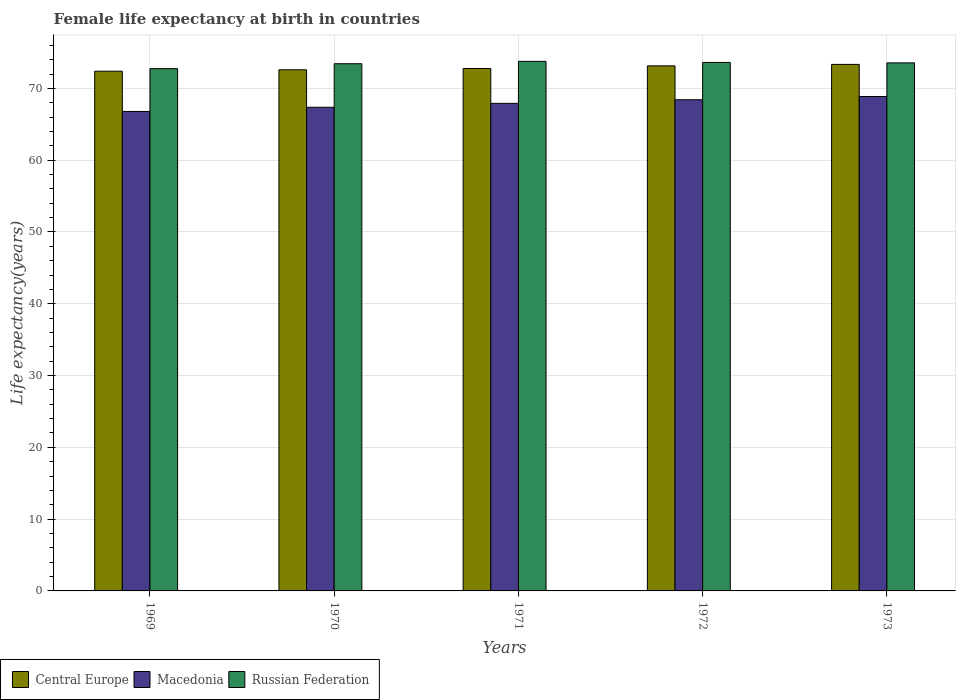How many different coloured bars are there?
Your response must be concise. 3. How many groups of bars are there?
Give a very brief answer. 5. Are the number of bars per tick equal to the number of legend labels?
Keep it short and to the point. Yes. Are the number of bars on each tick of the X-axis equal?
Offer a terse response. Yes. What is the label of the 1st group of bars from the left?
Provide a short and direct response. 1969. What is the female life expectancy at birth in Macedonia in 1971?
Provide a short and direct response. 67.92. Across all years, what is the maximum female life expectancy at birth in Macedonia?
Give a very brief answer. 68.87. Across all years, what is the minimum female life expectancy at birth in Macedonia?
Your answer should be very brief. 66.79. In which year was the female life expectancy at birth in Macedonia maximum?
Make the answer very short. 1973. In which year was the female life expectancy at birth in Macedonia minimum?
Offer a terse response. 1969. What is the total female life expectancy at birth in Macedonia in the graph?
Give a very brief answer. 339.38. What is the difference between the female life expectancy at birth in Russian Federation in 1971 and that in 1973?
Your answer should be compact. 0.21. What is the difference between the female life expectancy at birth in Macedonia in 1970 and the female life expectancy at birth in Central Europe in 1971?
Give a very brief answer. -5.4. What is the average female life expectancy at birth in Macedonia per year?
Make the answer very short. 67.88. In the year 1969, what is the difference between the female life expectancy at birth in Central Europe and female life expectancy at birth in Russian Federation?
Provide a succinct answer. -0.36. In how many years, is the female life expectancy at birth in Macedonia greater than 54 years?
Your answer should be very brief. 5. What is the ratio of the female life expectancy at birth in Central Europe in 1971 to that in 1972?
Make the answer very short. 1. Is the difference between the female life expectancy at birth in Central Europe in 1969 and 1971 greater than the difference between the female life expectancy at birth in Russian Federation in 1969 and 1971?
Give a very brief answer. Yes. What is the difference between the highest and the second highest female life expectancy at birth in Macedonia?
Provide a succinct answer. 0.45. What is the difference between the highest and the lowest female life expectancy at birth in Macedonia?
Make the answer very short. 2.08. Is the sum of the female life expectancy at birth in Russian Federation in 1970 and 1973 greater than the maximum female life expectancy at birth in Macedonia across all years?
Ensure brevity in your answer.  Yes. What does the 1st bar from the left in 1970 represents?
Your response must be concise. Central Europe. What does the 1st bar from the right in 1972 represents?
Provide a succinct answer. Russian Federation. Is it the case that in every year, the sum of the female life expectancy at birth in Central Europe and female life expectancy at birth in Macedonia is greater than the female life expectancy at birth in Russian Federation?
Your answer should be compact. Yes. How many bars are there?
Keep it short and to the point. 15. How many years are there in the graph?
Provide a succinct answer. 5. What is the difference between two consecutive major ticks on the Y-axis?
Offer a very short reply. 10. How many legend labels are there?
Give a very brief answer. 3. How are the legend labels stacked?
Your response must be concise. Horizontal. What is the title of the graph?
Offer a terse response. Female life expectancy at birth in countries. What is the label or title of the Y-axis?
Ensure brevity in your answer.  Life expectancy(years). What is the Life expectancy(years) of Central Europe in 1969?
Your answer should be compact. 72.4. What is the Life expectancy(years) of Macedonia in 1969?
Offer a very short reply. 66.79. What is the Life expectancy(years) of Russian Federation in 1969?
Provide a succinct answer. 72.75. What is the Life expectancy(years) of Central Europe in 1970?
Give a very brief answer. 72.59. What is the Life expectancy(years) of Macedonia in 1970?
Provide a succinct answer. 67.37. What is the Life expectancy(years) of Russian Federation in 1970?
Offer a very short reply. 73.44. What is the Life expectancy(years) of Central Europe in 1971?
Offer a very short reply. 72.78. What is the Life expectancy(years) of Macedonia in 1971?
Keep it short and to the point. 67.92. What is the Life expectancy(years) in Russian Federation in 1971?
Offer a terse response. 73.77. What is the Life expectancy(years) in Central Europe in 1972?
Give a very brief answer. 73.14. What is the Life expectancy(years) of Macedonia in 1972?
Keep it short and to the point. 68.42. What is the Life expectancy(years) in Russian Federation in 1972?
Your answer should be compact. 73.62. What is the Life expectancy(years) of Central Europe in 1973?
Keep it short and to the point. 73.35. What is the Life expectancy(years) in Macedonia in 1973?
Make the answer very short. 68.87. What is the Life expectancy(years) in Russian Federation in 1973?
Make the answer very short. 73.56. Across all years, what is the maximum Life expectancy(years) of Central Europe?
Make the answer very short. 73.35. Across all years, what is the maximum Life expectancy(years) in Macedonia?
Your response must be concise. 68.87. Across all years, what is the maximum Life expectancy(years) in Russian Federation?
Make the answer very short. 73.77. Across all years, what is the minimum Life expectancy(years) of Central Europe?
Give a very brief answer. 72.4. Across all years, what is the minimum Life expectancy(years) in Macedonia?
Make the answer very short. 66.79. Across all years, what is the minimum Life expectancy(years) in Russian Federation?
Ensure brevity in your answer.  72.75. What is the total Life expectancy(years) in Central Europe in the graph?
Your response must be concise. 364.25. What is the total Life expectancy(years) of Macedonia in the graph?
Offer a terse response. 339.38. What is the total Life expectancy(years) of Russian Federation in the graph?
Provide a short and direct response. 367.14. What is the difference between the Life expectancy(years) of Central Europe in 1969 and that in 1970?
Keep it short and to the point. -0.2. What is the difference between the Life expectancy(years) in Macedonia in 1969 and that in 1970?
Your answer should be compact. -0.58. What is the difference between the Life expectancy(years) of Russian Federation in 1969 and that in 1970?
Your answer should be compact. -0.69. What is the difference between the Life expectancy(years) in Central Europe in 1969 and that in 1971?
Offer a very short reply. -0.38. What is the difference between the Life expectancy(years) of Macedonia in 1969 and that in 1971?
Provide a short and direct response. -1.12. What is the difference between the Life expectancy(years) in Russian Federation in 1969 and that in 1971?
Your response must be concise. -1.01. What is the difference between the Life expectancy(years) of Central Europe in 1969 and that in 1972?
Offer a terse response. -0.74. What is the difference between the Life expectancy(years) of Macedonia in 1969 and that in 1972?
Offer a terse response. -1.63. What is the difference between the Life expectancy(years) in Russian Federation in 1969 and that in 1972?
Make the answer very short. -0.86. What is the difference between the Life expectancy(years) in Central Europe in 1969 and that in 1973?
Make the answer very short. -0.95. What is the difference between the Life expectancy(years) in Macedonia in 1969 and that in 1973?
Your answer should be very brief. -2.08. What is the difference between the Life expectancy(years) of Russian Federation in 1969 and that in 1973?
Your answer should be very brief. -0.81. What is the difference between the Life expectancy(years) of Central Europe in 1970 and that in 1971?
Make the answer very short. -0.18. What is the difference between the Life expectancy(years) of Macedonia in 1970 and that in 1971?
Your response must be concise. -0.55. What is the difference between the Life expectancy(years) in Russian Federation in 1970 and that in 1971?
Offer a very short reply. -0.33. What is the difference between the Life expectancy(years) in Central Europe in 1970 and that in 1972?
Give a very brief answer. -0.55. What is the difference between the Life expectancy(years) in Macedonia in 1970 and that in 1972?
Your response must be concise. -1.05. What is the difference between the Life expectancy(years) of Russian Federation in 1970 and that in 1972?
Your response must be concise. -0.18. What is the difference between the Life expectancy(years) of Central Europe in 1970 and that in 1973?
Provide a succinct answer. -0.75. What is the difference between the Life expectancy(years) of Macedonia in 1970 and that in 1973?
Provide a succinct answer. -1.5. What is the difference between the Life expectancy(years) in Russian Federation in 1970 and that in 1973?
Give a very brief answer. -0.12. What is the difference between the Life expectancy(years) of Central Europe in 1971 and that in 1972?
Provide a short and direct response. -0.37. What is the difference between the Life expectancy(years) in Macedonia in 1971 and that in 1972?
Offer a terse response. -0.5. What is the difference between the Life expectancy(years) in Russian Federation in 1971 and that in 1972?
Offer a terse response. 0.15. What is the difference between the Life expectancy(years) of Central Europe in 1971 and that in 1973?
Your answer should be very brief. -0.57. What is the difference between the Life expectancy(years) in Macedonia in 1971 and that in 1973?
Make the answer very short. -0.95. What is the difference between the Life expectancy(years) of Russian Federation in 1971 and that in 1973?
Make the answer very short. 0.21. What is the difference between the Life expectancy(years) in Central Europe in 1972 and that in 1973?
Offer a very short reply. -0.21. What is the difference between the Life expectancy(years) of Macedonia in 1972 and that in 1973?
Provide a short and direct response. -0.45. What is the difference between the Life expectancy(years) of Russian Federation in 1972 and that in 1973?
Your answer should be very brief. 0.06. What is the difference between the Life expectancy(years) of Central Europe in 1969 and the Life expectancy(years) of Macedonia in 1970?
Give a very brief answer. 5.02. What is the difference between the Life expectancy(years) of Central Europe in 1969 and the Life expectancy(years) of Russian Federation in 1970?
Your response must be concise. -1.04. What is the difference between the Life expectancy(years) in Macedonia in 1969 and the Life expectancy(years) in Russian Federation in 1970?
Your response must be concise. -6.65. What is the difference between the Life expectancy(years) in Central Europe in 1969 and the Life expectancy(years) in Macedonia in 1971?
Your answer should be compact. 4.48. What is the difference between the Life expectancy(years) in Central Europe in 1969 and the Life expectancy(years) in Russian Federation in 1971?
Keep it short and to the point. -1.37. What is the difference between the Life expectancy(years) of Macedonia in 1969 and the Life expectancy(years) of Russian Federation in 1971?
Offer a terse response. -6.98. What is the difference between the Life expectancy(years) in Central Europe in 1969 and the Life expectancy(years) in Macedonia in 1972?
Give a very brief answer. 3.98. What is the difference between the Life expectancy(years) of Central Europe in 1969 and the Life expectancy(years) of Russian Federation in 1972?
Your answer should be very brief. -1.22. What is the difference between the Life expectancy(years) of Macedonia in 1969 and the Life expectancy(years) of Russian Federation in 1972?
Offer a terse response. -6.83. What is the difference between the Life expectancy(years) in Central Europe in 1969 and the Life expectancy(years) in Macedonia in 1973?
Ensure brevity in your answer.  3.52. What is the difference between the Life expectancy(years) of Central Europe in 1969 and the Life expectancy(years) of Russian Federation in 1973?
Provide a short and direct response. -1.16. What is the difference between the Life expectancy(years) in Macedonia in 1969 and the Life expectancy(years) in Russian Federation in 1973?
Your answer should be very brief. -6.77. What is the difference between the Life expectancy(years) in Central Europe in 1970 and the Life expectancy(years) in Macedonia in 1971?
Offer a terse response. 4.67. What is the difference between the Life expectancy(years) of Central Europe in 1970 and the Life expectancy(years) of Russian Federation in 1971?
Give a very brief answer. -1.18. What is the difference between the Life expectancy(years) of Macedonia in 1970 and the Life expectancy(years) of Russian Federation in 1971?
Keep it short and to the point. -6.4. What is the difference between the Life expectancy(years) in Central Europe in 1970 and the Life expectancy(years) in Macedonia in 1972?
Offer a terse response. 4.17. What is the difference between the Life expectancy(years) of Central Europe in 1970 and the Life expectancy(years) of Russian Federation in 1972?
Your response must be concise. -1.03. What is the difference between the Life expectancy(years) of Macedonia in 1970 and the Life expectancy(years) of Russian Federation in 1972?
Ensure brevity in your answer.  -6.25. What is the difference between the Life expectancy(years) of Central Europe in 1970 and the Life expectancy(years) of Macedonia in 1973?
Your response must be concise. 3.72. What is the difference between the Life expectancy(years) of Central Europe in 1970 and the Life expectancy(years) of Russian Federation in 1973?
Your answer should be compact. -0.97. What is the difference between the Life expectancy(years) in Macedonia in 1970 and the Life expectancy(years) in Russian Federation in 1973?
Ensure brevity in your answer.  -6.19. What is the difference between the Life expectancy(years) of Central Europe in 1971 and the Life expectancy(years) of Macedonia in 1972?
Ensure brevity in your answer.  4.36. What is the difference between the Life expectancy(years) in Central Europe in 1971 and the Life expectancy(years) in Russian Federation in 1972?
Make the answer very short. -0.84. What is the difference between the Life expectancy(years) in Macedonia in 1971 and the Life expectancy(years) in Russian Federation in 1972?
Offer a very short reply. -5.7. What is the difference between the Life expectancy(years) of Central Europe in 1971 and the Life expectancy(years) of Macedonia in 1973?
Offer a very short reply. 3.9. What is the difference between the Life expectancy(years) of Central Europe in 1971 and the Life expectancy(years) of Russian Federation in 1973?
Your answer should be compact. -0.78. What is the difference between the Life expectancy(years) in Macedonia in 1971 and the Life expectancy(years) in Russian Federation in 1973?
Keep it short and to the point. -5.64. What is the difference between the Life expectancy(years) in Central Europe in 1972 and the Life expectancy(years) in Macedonia in 1973?
Offer a terse response. 4.27. What is the difference between the Life expectancy(years) in Central Europe in 1972 and the Life expectancy(years) in Russian Federation in 1973?
Make the answer very short. -0.42. What is the difference between the Life expectancy(years) of Macedonia in 1972 and the Life expectancy(years) of Russian Federation in 1973?
Give a very brief answer. -5.14. What is the average Life expectancy(years) of Central Europe per year?
Give a very brief answer. 72.85. What is the average Life expectancy(years) of Macedonia per year?
Offer a terse response. 67.88. What is the average Life expectancy(years) of Russian Federation per year?
Your answer should be very brief. 73.43. In the year 1969, what is the difference between the Life expectancy(years) of Central Europe and Life expectancy(years) of Macedonia?
Offer a terse response. 5.6. In the year 1969, what is the difference between the Life expectancy(years) of Central Europe and Life expectancy(years) of Russian Federation?
Provide a short and direct response. -0.36. In the year 1969, what is the difference between the Life expectancy(years) of Macedonia and Life expectancy(years) of Russian Federation?
Make the answer very short. -5.96. In the year 1970, what is the difference between the Life expectancy(years) of Central Europe and Life expectancy(years) of Macedonia?
Your answer should be very brief. 5.22. In the year 1970, what is the difference between the Life expectancy(years) in Central Europe and Life expectancy(years) in Russian Federation?
Your response must be concise. -0.85. In the year 1970, what is the difference between the Life expectancy(years) in Macedonia and Life expectancy(years) in Russian Federation?
Ensure brevity in your answer.  -6.07. In the year 1971, what is the difference between the Life expectancy(years) of Central Europe and Life expectancy(years) of Macedonia?
Your answer should be compact. 4.86. In the year 1971, what is the difference between the Life expectancy(years) in Central Europe and Life expectancy(years) in Russian Federation?
Your response must be concise. -0.99. In the year 1971, what is the difference between the Life expectancy(years) in Macedonia and Life expectancy(years) in Russian Federation?
Provide a succinct answer. -5.85. In the year 1972, what is the difference between the Life expectancy(years) in Central Europe and Life expectancy(years) in Macedonia?
Provide a succinct answer. 4.72. In the year 1972, what is the difference between the Life expectancy(years) of Central Europe and Life expectancy(years) of Russian Federation?
Offer a terse response. -0.48. In the year 1972, what is the difference between the Life expectancy(years) of Macedonia and Life expectancy(years) of Russian Federation?
Provide a succinct answer. -5.2. In the year 1973, what is the difference between the Life expectancy(years) of Central Europe and Life expectancy(years) of Macedonia?
Your response must be concise. 4.47. In the year 1973, what is the difference between the Life expectancy(years) in Central Europe and Life expectancy(years) in Russian Federation?
Your answer should be compact. -0.21. In the year 1973, what is the difference between the Life expectancy(years) of Macedonia and Life expectancy(years) of Russian Federation?
Your answer should be compact. -4.69. What is the ratio of the Life expectancy(years) in Central Europe in 1969 to that in 1970?
Your answer should be compact. 1. What is the ratio of the Life expectancy(years) of Macedonia in 1969 to that in 1970?
Make the answer very short. 0.99. What is the ratio of the Life expectancy(years) of Russian Federation in 1969 to that in 1970?
Give a very brief answer. 0.99. What is the ratio of the Life expectancy(years) of Macedonia in 1969 to that in 1971?
Your response must be concise. 0.98. What is the ratio of the Life expectancy(years) in Russian Federation in 1969 to that in 1971?
Give a very brief answer. 0.99. What is the ratio of the Life expectancy(years) in Macedonia in 1969 to that in 1972?
Keep it short and to the point. 0.98. What is the ratio of the Life expectancy(years) of Russian Federation in 1969 to that in 1972?
Your answer should be very brief. 0.99. What is the ratio of the Life expectancy(years) of Central Europe in 1969 to that in 1973?
Your response must be concise. 0.99. What is the ratio of the Life expectancy(years) of Macedonia in 1969 to that in 1973?
Make the answer very short. 0.97. What is the ratio of the Life expectancy(years) in Russian Federation in 1970 to that in 1971?
Give a very brief answer. 1. What is the ratio of the Life expectancy(years) of Macedonia in 1970 to that in 1972?
Make the answer very short. 0.98. What is the ratio of the Life expectancy(years) in Central Europe in 1970 to that in 1973?
Offer a very short reply. 0.99. What is the ratio of the Life expectancy(years) in Macedonia in 1970 to that in 1973?
Make the answer very short. 0.98. What is the ratio of the Life expectancy(years) of Russian Federation in 1970 to that in 1973?
Make the answer very short. 1. What is the ratio of the Life expectancy(years) of Macedonia in 1971 to that in 1972?
Keep it short and to the point. 0.99. What is the ratio of the Life expectancy(years) in Central Europe in 1971 to that in 1973?
Offer a very short reply. 0.99. What is the ratio of the Life expectancy(years) in Macedonia in 1971 to that in 1973?
Your answer should be compact. 0.99. What is the ratio of the Life expectancy(years) in Central Europe in 1972 to that in 1973?
Give a very brief answer. 1. What is the ratio of the Life expectancy(years) in Macedonia in 1972 to that in 1973?
Your answer should be compact. 0.99. What is the difference between the highest and the second highest Life expectancy(years) of Central Europe?
Your response must be concise. 0.21. What is the difference between the highest and the second highest Life expectancy(years) in Macedonia?
Your response must be concise. 0.45. What is the difference between the highest and the second highest Life expectancy(years) of Russian Federation?
Offer a terse response. 0.15. What is the difference between the highest and the lowest Life expectancy(years) of Central Europe?
Keep it short and to the point. 0.95. What is the difference between the highest and the lowest Life expectancy(years) of Macedonia?
Make the answer very short. 2.08. What is the difference between the highest and the lowest Life expectancy(years) of Russian Federation?
Your answer should be very brief. 1.01. 